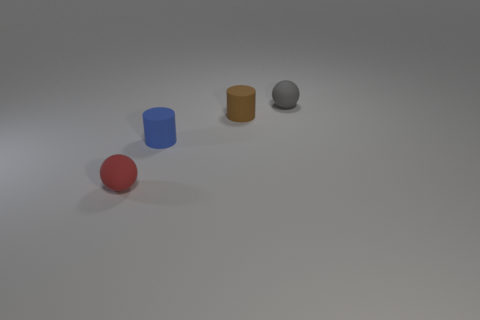Subtract all brown cubes. How many purple spheres are left? 0 Add 4 purple metal cylinders. How many purple metal cylinders exist? 4 Add 1 tiny rubber objects. How many objects exist? 5 Subtract 0 brown spheres. How many objects are left? 4 Subtract all cyan cylinders. Subtract all purple blocks. How many cylinders are left? 2 Subtract all tiny cyan shiny blocks. Subtract all tiny gray rubber things. How many objects are left? 3 Add 2 small brown rubber things. How many small brown rubber things are left? 3 